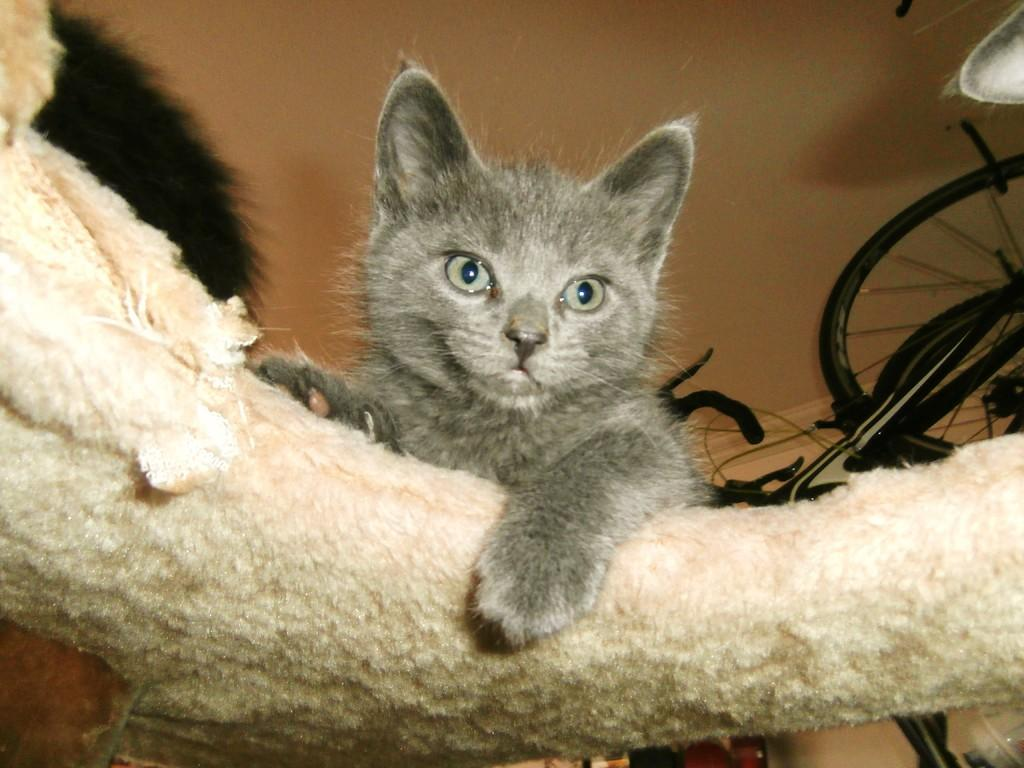What is the main subject in the center of the picture? There is a cat in the center of the picture. What is the cat doing in the image? The cat is placing its leg on a white color object. What other object can be seen in the image? There is a bicycle visible in the image. What is the color of the wall in the image? There is a wall in the image, which has a cream color. What type of celery is the cat eating in the image? There is no celery present in the image; the cat is placing its leg on a white color object. What is the reaction of the kitten when it sees the cat in the image? There is no kitten present in the image, so it is not possible to determine its reaction. 